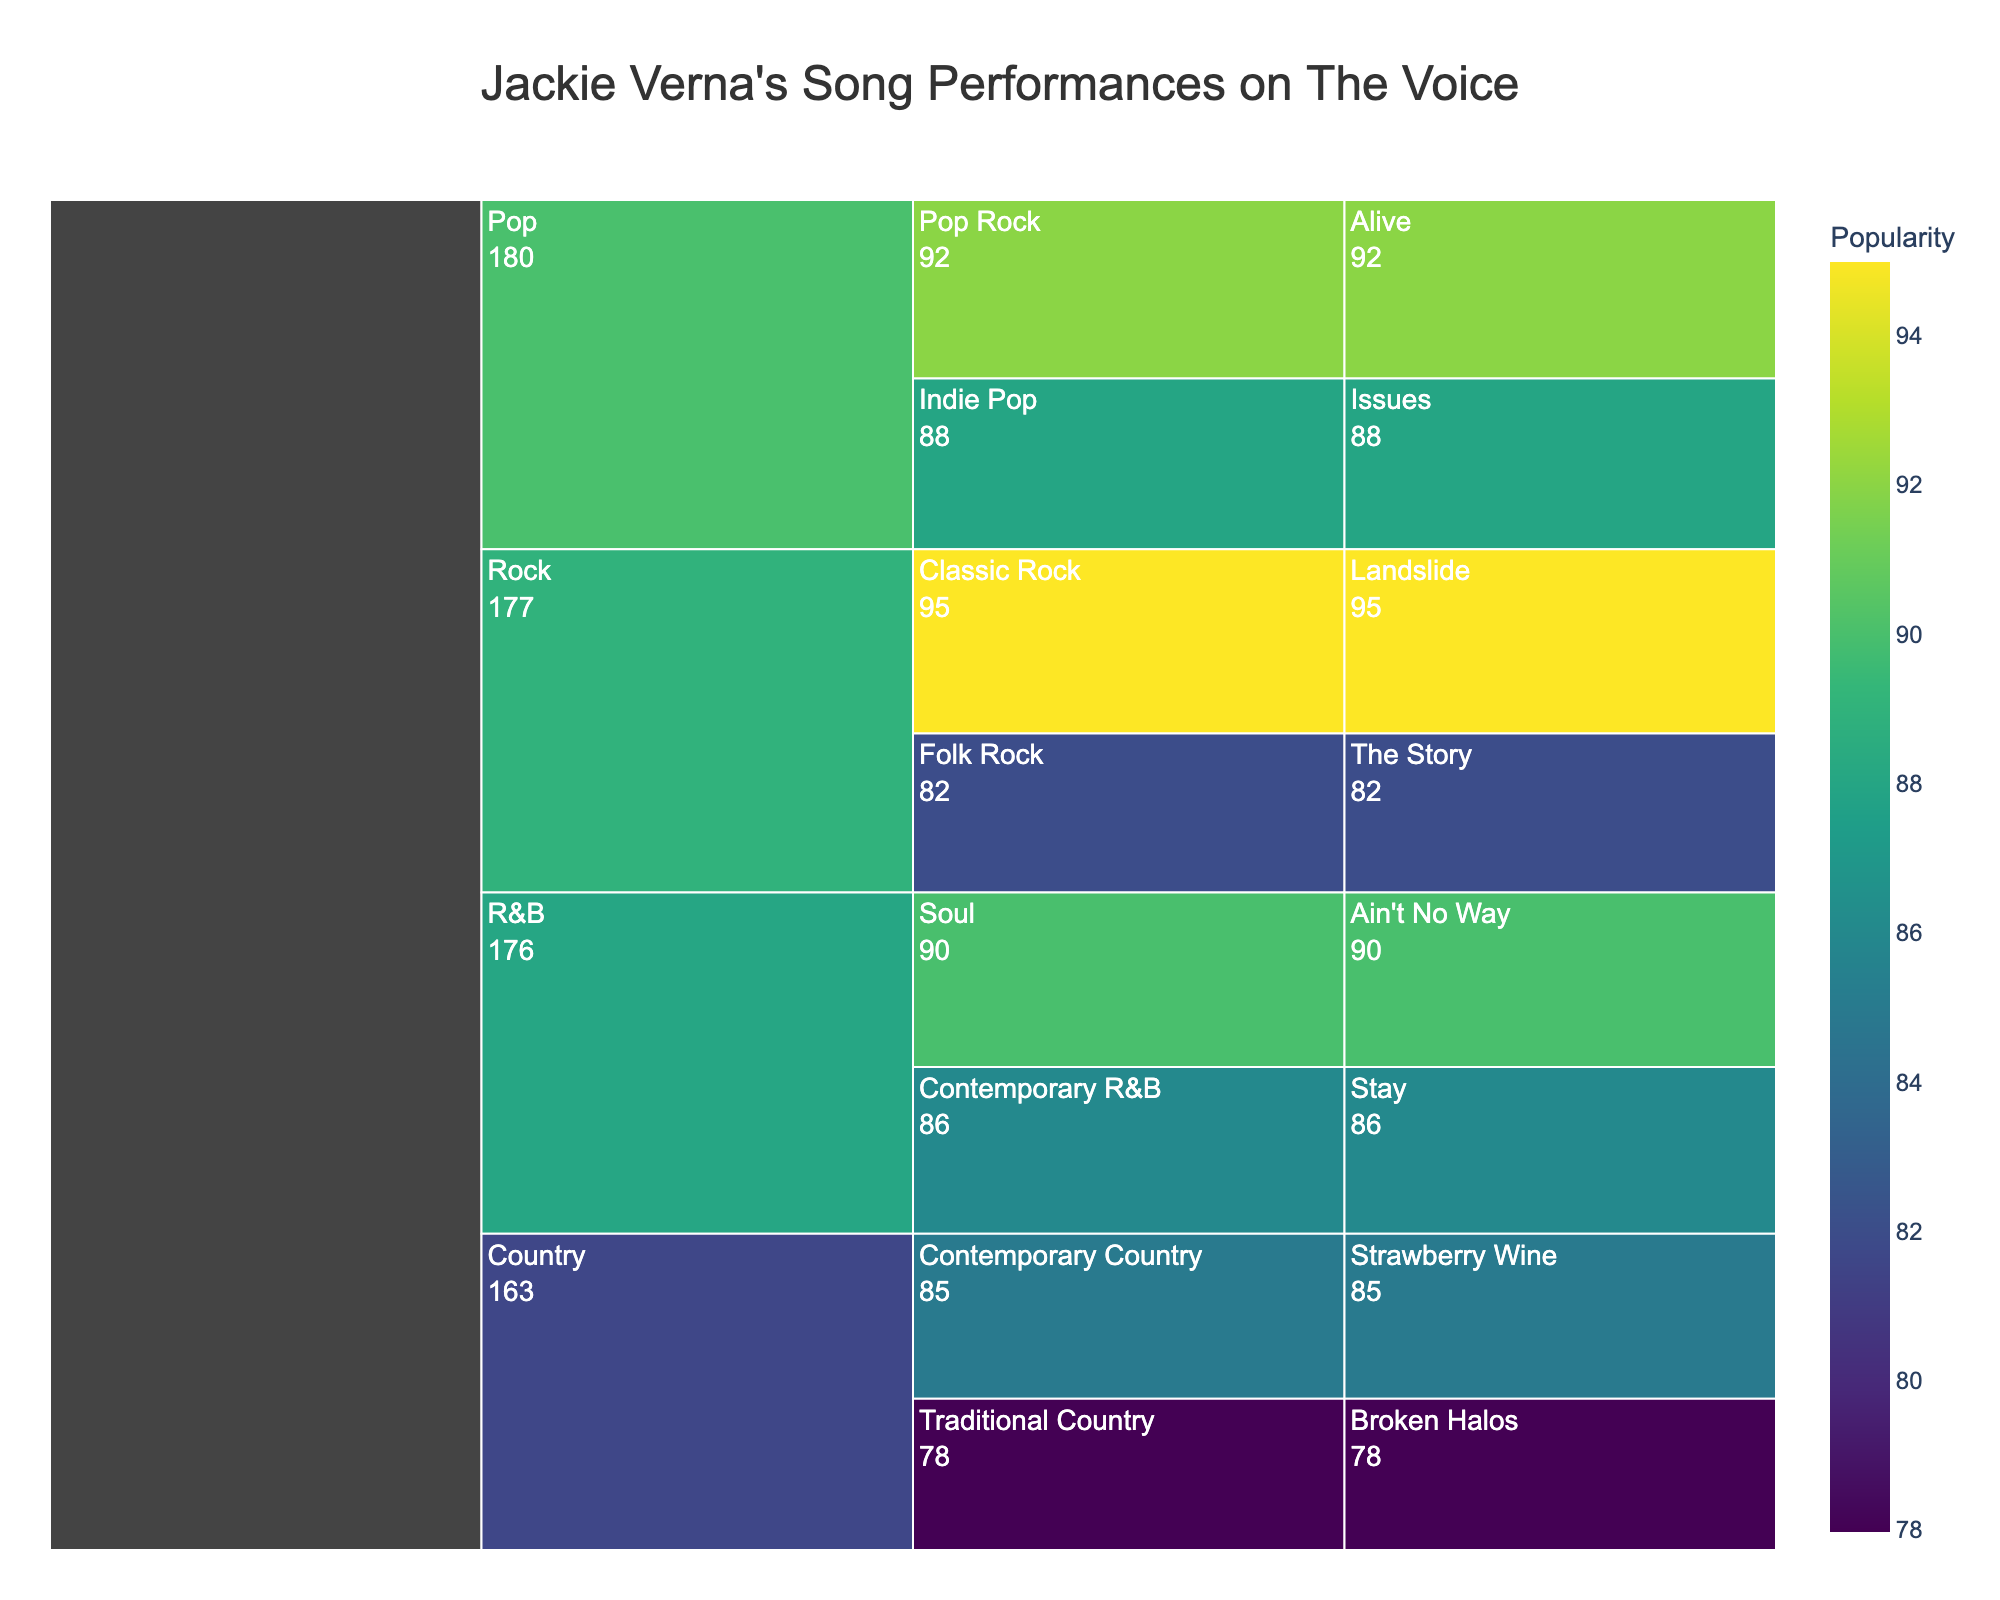What's the title of the chart? The title is displayed at the top of the chart and helps understand the subject of the visualization.
Answer: "Jackie Verna's Song Performances on The Voice" How many genres did Jackie Verna perform in? Count the unique genres directly listed in the icicle chart's hierarchical structure.
Answer: 4 Which song has the highest popularity score? Identify the song with the highest value in the icicle chart.
Answer: "Landslide" Which subgenre does "The Story" belong to? Trace the hierarchy from the song label "The Story" to its parent subgenre in the chart.
Answer: Folk Rock What is the average popularity score for the songs in the Pop genre? Sum the popularity scores of "Alive" and "Issues" and then divide by 2, as there are two songs.
Answer: (92 + 88) / 2 = 90 Which subgenre within Country has the lower popularity score? Compare the popularity scores of "Strawberry Wine" and "Broken Halos" in the respective subgenre labels.
Answer: Traditional Country How many songs did Jackie perform in the R&B genre? Count the number of songs directly under the R&B genre label in the chart.
Answer: 2 Which subgenre has the song with the lowest popularity score? Find the subgenre of the song with the lowest value in the chart's hierarchy.
Answer: Traditional Country What is the range of popularity scores within the Rock genre? Subtract the lowest popularity score among "Landslide" and "The Story" from the highest popularity score in that genre.
Answer: 95 - 82 = 13 If you sum the popularity scores of all songs, what is the total? Add up the popularity values of all songs in the chart to find the total.
Answer: 85 + 78 + 92 + 88 + 95 + 82 + 90 + 86 = 696 